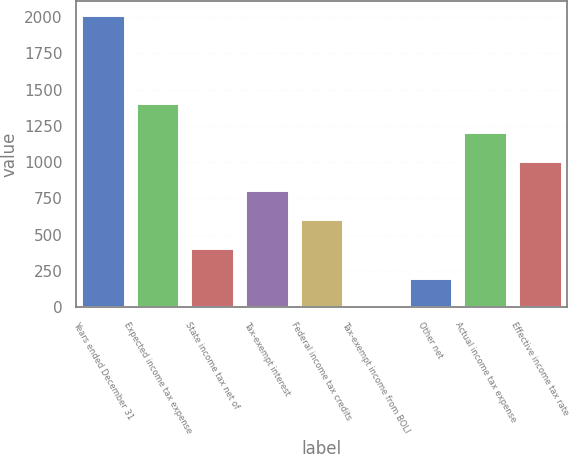Convert chart. <chart><loc_0><loc_0><loc_500><loc_500><bar_chart><fcel>Years ended December 31<fcel>Expected income tax expense<fcel>State income tax net of<fcel>Tax-exempt interest<fcel>Federal income tax credits<fcel>Tax-exempt income from BOLI<fcel>Other net<fcel>Actual income tax expense<fcel>Effective income tax rate<nl><fcel>2013<fcel>1409.58<fcel>403.88<fcel>806.16<fcel>605.02<fcel>1.6<fcel>202.74<fcel>1208.44<fcel>1007.3<nl></chart> 